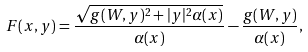<formula> <loc_0><loc_0><loc_500><loc_500>F ( x , y ) = \frac { \sqrt { g ( W , y ) ^ { 2 } + | y | ^ { 2 } \alpha ( x ) } } { \alpha ( x ) } - \frac { g ( W , y ) } { \alpha ( x ) } ,</formula> 